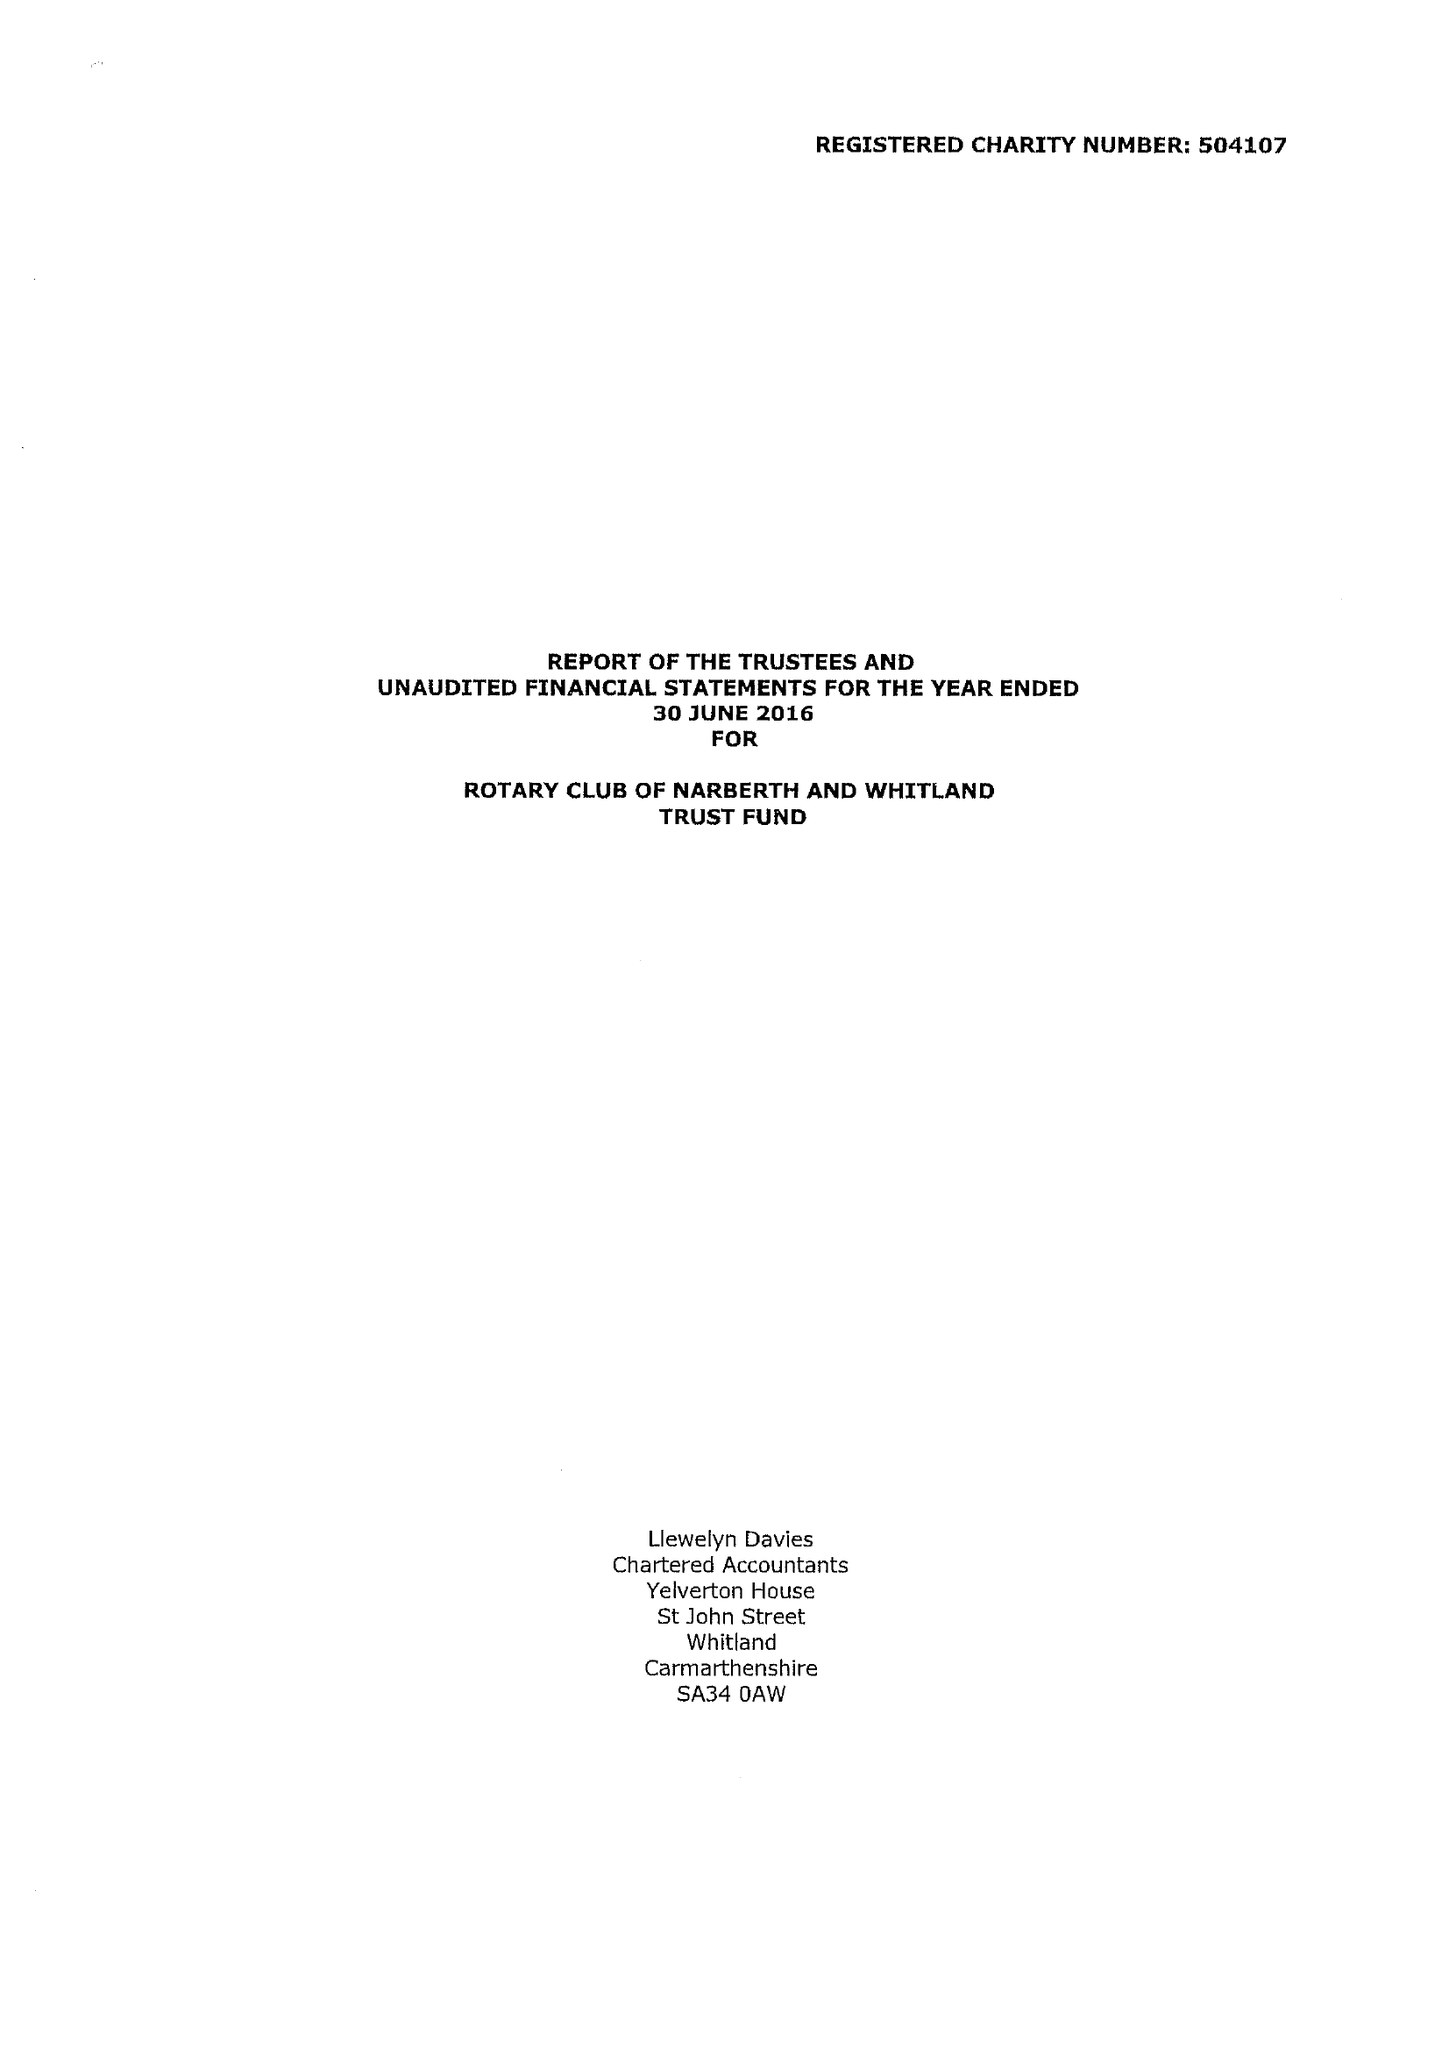What is the value for the address__postcode?
Answer the question using a single word or phrase. SA67 8RP 